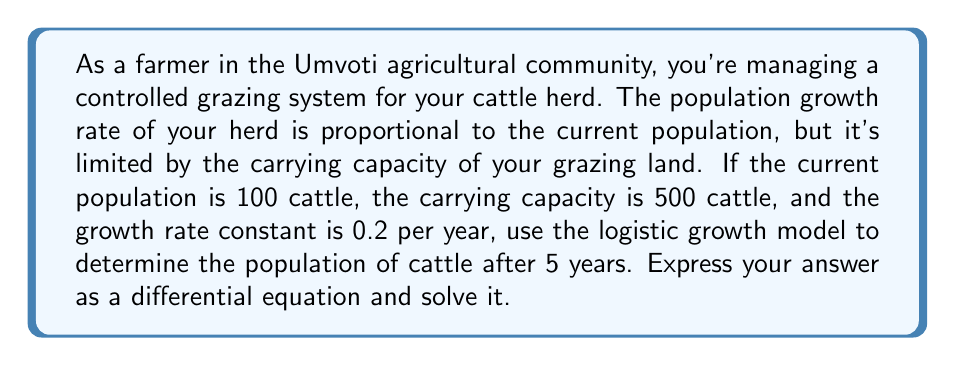Can you solve this math problem? Let's approach this step-by-step:

1) The logistic growth model is given by the differential equation:

   $$\frac{dP}{dt} = rP(1 - \frac{P}{K})$$

   Where:
   $P$ is the population
   $t$ is time
   $r$ is the growth rate constant
   $K$ is the carrying capacity

2) We're given:
   $P(0) = 100$ (initial population)
   $K = 500$ (carrying capacity)
   $r = 0.2$ (growth rate constant)

3) Substituting these values into the differential equation:

   $$\frac{dP}{dt} = 0.2P(1 - \frac{P}{500})$$

4) This is a separable differential equation. We can solve it as follows:

   $$\int \frac{dP}{P(1 - \frac{P}{500})} = \int 0.2 dt$$

5) The left side can be integrated using partial fractions:

   $$\ln|P| - \ln|500-P| = 0.2t + C$$

6) Simplifying and applying the initial condition $P(0) = 100$:

   $$\ln(\frac{P}{500-P}) = 0.2t + \ln(\frac{100}{400})$$

7) Solving for $P$:

   $$P = \frac{500}{1 + 4e^{-0.2t}}$$

8) To find the population after 5 years, we substitute $t = 5$:

   $$P(5) = \frac{500}{1 + 4e^{-0.2(5)}} \approx 303.87$$

Therefore, after 5 years, the cattle population will be approximately 304 (rounding to the nearest whole number).
Answer: The population of cattle after 5 years will be approximately 304. 